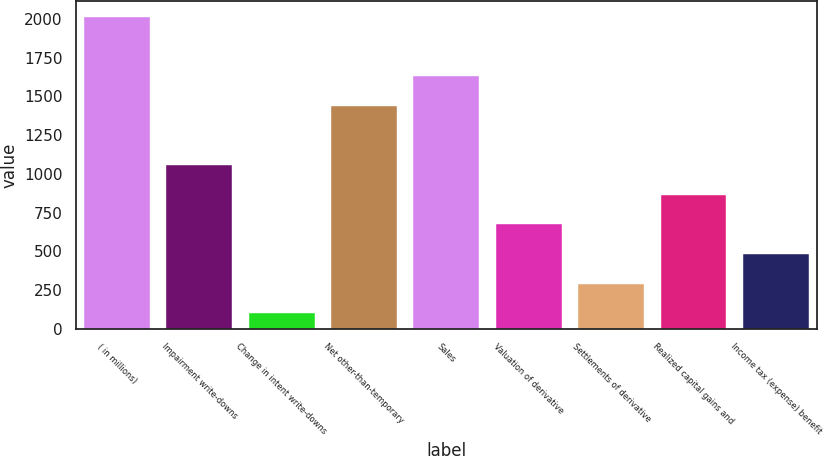Convert chart to OTSL. <chart><loc_0><loc_0><loc_500><loc_500><bar_chart><fcel>( in millions)<fcel>Impairment write-downs<fcel>Change in intent write-downs<fcel>Net other-than-temporary<fcel>Sales<fcel>Valuation of derivative<fcel>Settlements of derivative<fcel>Realized capital gains and<fcel>Income tax (expense) benefit<nl><fcel>2011<fcel>1055.5<fcel>100<fcel>1437.7<fcel>1628.8<fcel>673.3<fcel>291.1<fcel>864.4<fcel>482.2<nl></chart> 